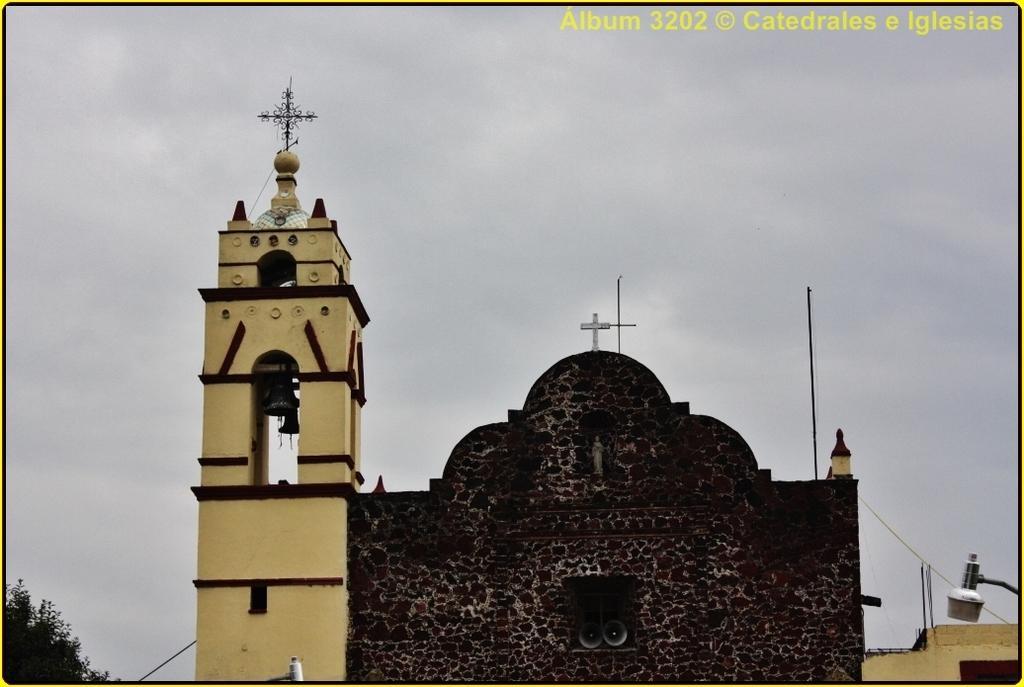Please provide a concise description of this image. In this image there is a building in the middle. At the top there is the sky. On the right side bottom there is a light. On the left side bottom there is a tree. There is a cross symbol above the building. 